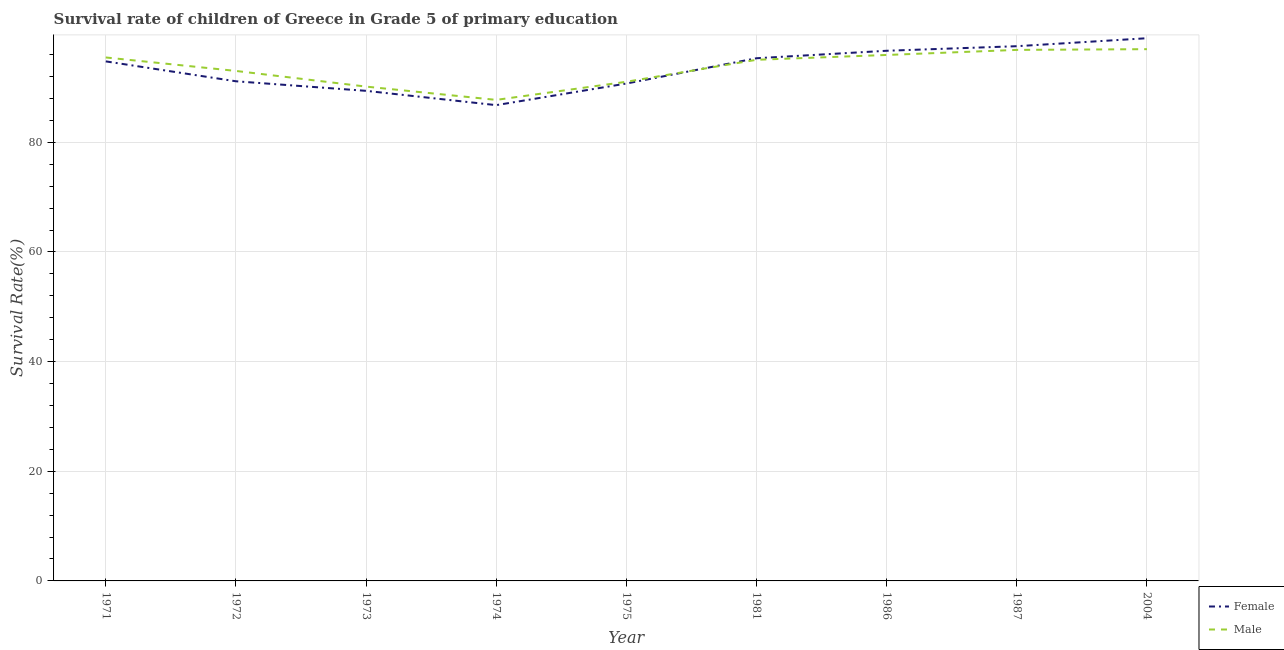How many different coloured lines are there?
Ensure brevity in your answer.  2. Does the line corresponding to survival rate of male students in primary education intersect with the line corresponding to survival rate of female students in primary education?
Your answer should be very brief. Yes. Is the number of lines equal to the number of legend labels?
Offer a very short reply. Yes. What is the survival rate of male students in primary education in 1981?
Ensure brevity in your answer.  95.05. Across all years, what is the maximum survival rate of male students in primary education?
Provide a short and direct response. 96.99. Across all years, what is the minimum survival rate of male students in primary education?
Offer a terse response. 87.74. In which year was the survival rate of female students in primary education maximum?
Your response must be concise. 2004. In which year was the survival rate of male students in primary education minimum?
Your answer should be compact. 1974. What is the total survival rate of female students in primary education in the graph?
Offer a very short reply. 841.33. What is the difference between the survival rate of female students in primary education in 1971 and that in 1975?
Offer a very short reply. 4.04. What is the difference between the survival rate of female students in primary education in 1981 and the survival rate of male students in primary education in 1975?
Offer a very short reply. 4.29. What is the average survival rate of female students in primary education per year?
Your answer should be compact. 93.48. In the year 2004, what is the difference between the survival rate of male students in primary education and survival rate of female students in primary education?
Ensure brevity in your answer.  -2. What is the ratio of the survival rate of female students in primary education in 1971 to that in 2004?
Offer a terse response. 0.96. Is the difference between the survival rate of male students in primary education in 1986 and 2004 greater than the difference between the survival rate of female students in primary education in 1986 and 2004?
Make the answer very short. Yes. What is the difference between the highest and the second highest survival rate of male students in primary education?
Offer a very short reply. 0.13. What is the difference between the highest and the lowest survival rate of female students in primary education?
Provide a succinct answer. 12.21. Is the sum of the survival rate of male students in primary education in 1973 and 1986 greater than the maximum survival rate of female students in primary education across all years?
Offer a terse response. Yes. Is the survival rate of male students in primary education strictly greater than the survival rate of female students in primary education over the years?
Ensure brevity in your answer.  No. Is the survival rate of male students in primary education strictly less than the survival rate of female students in primary education over the years?
Ensure brevity in your answer.  No. How many lines are there?
Keep it short and to the point. 2. How many years are there in the graph?
Your answer should be very brief. 9. What is the difference between two consecutive major ticks on the Y-axis?
Keep it short and to the point. 20. Are the values on the major ticks of Y-axis written in scientific E-notation?
Provide a short and direct response. No. Does the graph contain any zero values?
Offer a terse response. No. Does the graph contain grids?
Your answer should be compact. Yes. Where does the legend appear in the graph?
Offer a very short reply. Bottom right. How many legend labels are there?
Your answer should be very brief. 2. What is the title of the graph?
Your answer should be compact. Survival rate of children of Greece in Grade 5 of primary education. Does "Not attending school" appear as one of the legend labels in the graph?
Offer a terse response. No. What is the label or title of the Y-axis?
Provide a succinct answer. Survival Rate(%). What is the Survival Rate(%) of Female in 1971?
Offer a terse response. 94.76. What is the Survival Rate(%) of Male in 1971?
Keep it short and to the point. 95.48. What is the Survival Rate(%) of Female in 1972?
Ensure brevity in your answer.  91.13. What is the Survival Rate(%) of Male in 1972?
Keep it short and to the point. 93.02. What is the Survival Rate(%) of Female in 1973?
Your answer should be very brief. 89.39. What is the Survival Rate(%) in Male in 1973?
Make the answer very short. 90.16. What is the Survival Rate(%) in Female in 1974?
Offer a very short reply. 86.78. What is the Survival Rate(%) in Male in 1974?
Give a very brief answer. 87.74. What is the Survival Rate(%) of Female in 1975?
Your response must be concise. 90.72. What is the Survival Rate(%) in Male in 1975?
Keep it short and to the point. 91.04. What is the Survival Rate(%) of Female in 1981?
Ensure brevity in your answer.  95.33. What is the Survival Rate(%) in Male in 1981?
Keep it short and to the point. 95.05. What is the Survival Rate(%) in Female in 1986?
Offer a terse response. 96.7. What is the Survival Rate(%) of Male in 1986?
Offer a very short reply. 95.93. What is the Survival Rate(%) in Female in 1987?
Make the answer very short. 97.53. What is the Survival Rate(%) in Male in 1987?
Provide a succinct answer. 96.86. What is the Survival Rate(%) of Female in 2004?
Keep it short and to the point. 98.99. What is the Survival Rate(%) in Male in 2004?
Give a very brief answer. 96.99. Across all years, what is the maximum Survival Rate(%) of Female?
Your response must be concise. 98.99. Across all years, what is the maximum Survival Rate(%) in Male?
Keep it short and to the point. 96.99. Across all years, what is the minimum Survival Rate(%) of Female?
Offer a terse response. 86.78. Across all years, what is the minimum Survival Rate(%) in Male?
Ensure brevity in your answer.  87.74. What is the total Survival Rate(%) in Female in the graph?
Your response must be concise. 841.33. What is the total Survival Rate(%) of Male in the graph?
Provide a short and direct response. 842.27. What is the difference between the Survival Rate(%) of Female in 1971 and that in 1972?
Provide a short and direct response. 3.63. What is the difference between the Survival Rate(%) of Male in 1971 and that in 1972?
Provide a succinct answer. 2.46. What is the difference between the Survival Rate(%) in Female in 1971 and that in 1973?
Keep it short and to the point. 5.37. What is the difference between the Survival Rate(%) in Male in 1971 and that in 1973?
Offer a very short reply. 5.31. What is the difference between the Survival Rate(%) of Female in 1971 and that in 1974?
Make the answer very short. 7.98. What is the difference between the Survival Rate(%) in Male in 1971 and that in 1974?
Your response must be concise. 7.74. What is the difference between the Survival Rate(%) in Female in 1971 and that in 1975?
Provide a short and direct response. 4.04. What is the difference between the Survival Rate(%) of Male in 1971 and that in 1975?
Offer a terse response. 4.43. What is the difference between the Survival Rate(%) of Female in 1971 and that in 1981?
Keep it short and to the point. -0.57. What is the difference between the Survival Rate(%) in Male in 1971 and that in 1981?
Your answer should be very brief. 0.43. What is the difference between the Survival Rate(%) of Female in 1971 and that in 1986?
Give a very brief answer. -1.94. What is the difference between the Survival Rate(%) of Male in 1971 and that in 1986?
Your answer should be compact. -0.45. What is the difference between the Survival Rate(%) of Female in 1971 and that in 1987?
Keep it short and to the point. -2.77. What is the difference between the Survival Rate(%) in Male in 1971 and that in 1987?
Give a very brief answer. -1.38. What is the difference between the Survival Rate(%) in Female in 1971 and that in 2004?
Keep it short and to the point. -4.22. What is the difference between the Survival Rate(%) in Male in 1971 and that in 2004?
Provide a short and direct response. -1.51. What is the difference between the Survival Rate(%) of Female in 1972 and that in 1973?
Your answer should be compact. 1.74. What is the difference between the Survival Rate(%) of Male in 1972 and that in 1973?
Offer a very short reply. 2.86. What is the difference between the Survival Rate(%) of Female in 1972 and that in 1974?
Offer a terse response. 4.35. What is the difference between the Survival Rate(%) in Male in 1972 and that in 1974?
Keep it short and to the point. 5.28. What is the difference between the Survival Rate(%) of Female in 1972 and that in 1975?
Keep it short and to the point. 0.41. What is the difference between the Survival Rate(%) of Male in 1972 and that in 1975?
Offer a very short reply. 1.98. What is the difference between the Survival Rate(%) in Female in 1972 and that in 1981?
Your answer should be compact. -4.2. What is the difference between the Survival Rate(%) of Male in 1972 and that in 1981?
Offer a terse response. -2.03. What is the difference between the Survival Rate(%) of Female in 1972 and that in 1986?
Your answer should be very brief. -5.57. What is the difference between the Survival Rate(%) in Male in 1972 and that in 1986?
Offer a very short reply. -2.91. What is the difference between the Survival Rate(%) in Female in 1972 and that in 1987?
Provide a short and direct response. -6.4. What is the difference between the Survival Rate(%) of Male in 1972 and that in 1987?
Your answer should be compact. -3.84. What is the difference between the Survival Rate(%) of Female in 1972 and that in 2004?
Offer a terse response. -7.85. What is the difference between the Survival Rate(%) of Male in 1972 and that in 2004?
Offer a terse response. -3.97. What is the difference between the Survival Rate(%) in Female in 1973 and that in 1974?
Keep it short and to the point. 2.61. What is the difference between the Survival Rate(%) in Male in 1973 and that in 1974?
Your answer should be compact. 2.43. What is the difference between the Survival Rate(%) in Female in 1973 and that in 1975?
Offer a terse response. -1.33. What is the difference between the Survival Rate(%) in Male in 1973 and that in 1975?
Provide a succinct answer. -0.88. What is the difference between the Survival Rate(%) of Female in 1973 and that in 1981?
Your answer should be compact. -5.95. What is the difference between the Survival Rate(%) in Male in 1973 and that in 1981?
Your answer should be compact. -4.89. What is the difference between the Survival Rate(%) in Female in 1973 and that in 1986?
Offer a very short reply. -7.31. What is the difference between the Survival Rate(%) of Male in 1973 and that in 1986?
Your response must be concise. -5.77. What is the difference between the Survival Rate(%) of Female in 1973 and that in 1987?
Keep it short and to the point. -8.14. What is the difference between the Survival Rate(%) of Male in 1973 and that in 1987?
Your answer should be very brief. -6.69. What is the difference between the Survival Rate(%) of Female in 1973 and that in 2004?
Give a very brief answer. -9.6. What is the difference between the Survival Rate(%) of Male in 1973 and that in 2004?
Your answer should be compact. -6.83. What is the difference between the Survival Rate(%) in Female in 1974 and that in 1975?
Provide a succinct answer. -3.94. What is the difference between the Survival Rate(%) of Male in 1974 and that in 1975?
Keep it short and to the point. -3.31. What is the difference between the Survival Rate(%) of Female in 1974 and that in 1981?
Give a very brief answer. -8.55. What is the difference between the Survival Rate(%) in Male in 1974 and that in 1981?
Your response must be concise. -7.31. What is the difference between the Survival Rate(%) of Female in 1974 and that in 1986?
Offer a very short reply. -9.92. What is the difference between the Survival Rate(%) of Male in 1974 and that in 1986?
Your response must be concise. -8.19. What is the difference between the Survival Rate(%) of Female in 1974 and that in 1987?
Your answer should be compact. -10.75. What is the difference between the Survival Rate(%) of Male in 1974 and that in 1987?
Offer a terse response. -9.12. What is the difference between the Survival Rate(%) in Female in 1974 and that in 2004?
Provide a short and direct response. -12.21. What is the difference between the Survival Rate(%) in Male in 1974 and that in 2004?
Your response must be concise. -9.25. What is the difference between the Survival Rate(%) in Female in 1975 and that in 1981?
Provide a short and direct response. -4.61. What is the difference between the Survival Rate(%) of Male in 1975 and that in 1981?
Your answer should be very brief. -4.01. What is the difference between the Survival Rate(%) of Female in 1975 and that in 1986?
Make the answer very short. -5.98. What is the difference between the Survival Rate(%) in Male in 1975 and that in 1986?
Provide a succinct answer. -4.89. What is the difference between the Survival Rate(%) of Female in 1975 and that in 1987?
Your response must be concise. -6.81. What is the difference between the Survival Rate(%) in Male in 1975 and that in 1987?
Provide a short and direct response. -5.81. What is the difference between the Survival Rate(%) of Female in 1975 and that in 2004?
Your answer should be very brief. -8.27. What is the difference between the Survival Rate(%) of Male in 1975 and that in 2004?
Offer a very short reply. -5.95. What is the difference between the Survival Rate(%) of Female in 1981 and that in 1986?
Give a very brief answer. -1.36. What is the difference between the Survival Rate(%) of Male in 1981 and that in 1986?
Your answer should be very brief. -0.88. What is the difference between the Survival Rate(%) of Female in 1981 and that in 1987?
Ensure brevity in your answer.  -2.2. What is the difference between the Survival Rate(%) of Male in 1981 and that in 1987?
Your answer should be compact. -1.8. What is the difference between the Survival Rate(%) in Female in 1981 and that in 2004?
Make the answer very short. -3.65. What is the difference between the Survival Rate(%) in Male in 1981 and that in 2004?
Your answer should be compact. -1.94. What is the difference between the Survival Rate(%) in Female in 1986 and that in 1987?
Offer a very short reply. -0.83. What is the difference between the Survival Rate(%) of Male in 1986 and that in 1987?
Give a very brief answer. -0.92. What is the difference between the Survival Rate(%) of Female in 1986 and that in 2004?
Offer a very short reply. -2.29. What is the difference between the Survival Rate(%) of Male in 1986 and that in 2004?
Give a very brief answer. -1.06. What is the difference between the Survival Rate(%) of Female in 1987 and that in 2004?
Keep it short and to the point. -1.46. What is the difference between the Survival Rate(%) in Male in 1987 and that in 2004?
Keep it short and to the point. -0.13. What is the difference between the Survival Rate(%) of Female in 1971 and the Survival Rate(%) of Male in 1972?
Make the answer very short. 1.74. What is the difference between the Survival Rate(%) of Female in 1971 and the Survival Rate(%) of Male in 1973?
Make the answer very short. 4.6. What is the difference between the Survival Rate(%) of Female in 1971 and the Survival Rate(%) of Male in 1974?
Give a very brief answer. 7.02. What is the difference between the Survival Rate(%) of Female in 1971 and the Survival Rate(%) of Male in 1975?
Make the answer very short. 3.72. What is the difference between the Survival Rate(%) of Female in 1971 and the Survival Rate(%) of Male in 1981?
Your answer should be compact. -0.29. What is the difference between the Survival Rate(%) in Female in 1971 and the Survival Rate(%) in Male in 1986?
Your response must be concise. -1.17. What is the difference between the Survival Rate(%) in Female in 1971 and the Survival Rate(%) in Male in 1987?
Give a very brief answer. -2.09. What is the difference between the Survival Rate(%) in Female in 1971 and the Survival Rate(%) in Male in 2004?
Your response must be concise. -2.23. What is the difference between the Survival Rate(%) in Female in 1972 and the Survival Rate(%) in Male in 1973?
Ensure brevity in your answer.  0.97. What is the difference between the Survival Rate(%) of Female in 1972 and the Survival Rate(%) of Male in 1974?
Ensure brevity in your answer.  3.39. What is the difference between the Survival Rate(%) of Female in 1972 and the Survival Rate(%) of Male in 1975?
Offer a terse response. 0.09. What is the difference between the Survival Rate(%) in Female in 1972 and the Survival Rate(%) in Male in 1981?
Make the answer very short. -3.92. What is the difference between the Survival Rate(%) of Female in 1972 and the Survival Rate(%) of Male in 1986?
Offer a very short reply. -4.8. What is the difference between the Survival Rate(%) of Female in 1972 and the Survival Rate(%) of Male in 1987?
Your response must be concise. -5.72. What is the difference between the Survival Rate(%) of Female in 1972 and the Survival Rate(%) of Male in 2004?
Make the answer very short. -5.86. What is the difference between the Survival Rate(%) of Female in 1973 and the Survival Rate(%) of Male in 1974?
Your answer should be very brief. 1.65. What is the difference between the Survival Rate(%) of Female in 1973 and the Survival Rate(%) of Male in 1975?
Offer a very short reply. -1.65. What is the difference between the Survival Rate(%) of Female in 1973 and the Survival Rate(%) of Male in 1981?
Make the answer very short. -5.66. What is the difference between the Survival Rate(%) in Female in 1973 and the Survival Rate(%) in Male in 1986?
Give a very brief answer. -6.54. What is the difference between the Survival Rate(%) of Female in 1973 and the Survival Rate(%) of Male in 1987?
Your response must be concise. -7.47. What is the difference between the Survival Rate(%) of Female in 1973 and the Survival Rate(%) of Male in 2004?
Your answer should be very brief. -7.6. What is the difference between the Survival Rate(%) of Female in 1974 and the Survival Rate(%) of Male in 1975?
Your answer should be compact. -4.26. What is the difference between the Survival Rate(%) in Female in 1974 and the Survival Rate(%) in Male in 1981?
Make the answer very short. -8.27. What is the difference between the Survival Rate(%) in Female in 1974 and the Survival Rate(%) in Male in 1986?
Your answer should be compact. -9.15. What is the difference between the Survival Rate(%) of Female in 1974 and the Survival Rate(%) of Male in 1987?
Provide a succinct answer. -10.08. What is the difference between the Survival Rate(%) in Female in 1974 and the Survival Rate(%) in Male in 2004?
Offer a very short reply. -10.21. What is the difference between the Survival Rate(%) of Female in 1975 and the Survival Rate(%) of Male in 1981?
Keep it short and to the point. -4.33. What is the difference between the Survival Rate(%) of Female in 1975 and the Survival Rate(%) of Male in 1986?
Keep it short and to the point. -5.21. What is the difference between the Survival Rate(%) of Female in 1975 and the Survival Rate(%) of Male in 1987?
Offer a very short reply. -6.14. What is the difference between the Survival Rate(%) of Female in 1975 and the Survival Rate(%) of Male in 2004?
Provide a short and direct response. -6.27. What is the difference between the Survival Rate(%) in Female in 1981 and the Survival Rate(%) in Male in 1986?
Your response must be concise. -0.6. What is the difference between the Survival Rate(%) of Female in 1981 and the Survival Rate(%) of Male in 1987?
Offer a very short reply. -1.52. What is the difference between the Survival Rate(%) of Female in 1981 and the Survival Rate(%) of Male in 2004?
Your response must be concise. -1.66. What is the difference between the Survival Rate(%) in Female in 1986 and the Survival Rate(%) in Male in 1987?
Provide a short and direct response. -0.16. What is the difference between the Survival Rate(%) of Female in 1986 and the Survival Rate(%) of Male in 2004?
Give a very brief answer. -0.29. What is the difference between the Survival Rate(%) of Female in 1987 and the Survival Rate(%) of Male in 2004?
Offer a terse response. 0.54. What is the average Survival Rate(%) in Female per year?
Your answer should be compact. 93.48. What is the average Survival Rate(%) of Male per year?
Your answer should be compact. 93.59. In the year 1971, what is the difference between the Survival Rate(%) of Female and Survival Rate(%) of Male?
Provide a succinct answer. -0.72. In the year 1972, what is the difference between the Survival Rate(%) of Female and Survival Rate(%) of Male?
Your response must be concise. -1.89. In the year 1973, what is the difference between the Survival Rate(%) in Female and Survival Rate(%) in Male?
Give a very brief answer. -0.77. In the year 1974, what is the difference between the Survival Rate(%) of Female and Survival Rate(%) of Male?
Provide a short and direct response. -0.96. In the year 1975, what is the difference between the Survival Rate(%) in Female and Survival Rate(%) in Male?
Your answer should be compact. -0.32. In the year 1981, what is the difference between the Survival Rate(%) in Female and Survival Rate(%) in Male?
Keep it short and to the point. 0.28. In the year 1986, what is the difference between the Survival Rate(%) in Female and Survival Rate(%) in Male?
Ensure brevity in your answer.  0.77. In the year 1987, what is the difference between the Survival Rate(%) of Female and Survival Rate(%) of Male?
Offer a terse response. 0.67. In the year 2004, what is the difference between the Survival Rate(%) in Female and Survival Rate(%) in Male?
Keep it short and to the point. 2. What is the ratio of the Survival Rate(%) of Female in 1971 to that in 1972?
Your response must be concise. 1.04. What is the ratio of the Survival Rate(%) of Male in 1971 to that in 1972?
Offer a very short reply. 1.03. What is the ratio of the Survival Rate(%) of Female in 1971 to that in 1973?
Provide a succinct answer. 1.06. What is the ratio of the Survival Rate(%) of Male in 1971 to that in 1973?
Your answer should be compact. 1.06. What is the ratio of the Survival Rate(%) in Female in 1971 to that in 1974?
Your answer should be very brief. 1.09. What is the ratio of the Survival Rate(%) of Male in 1971 to that in 1974?
Provide a short and direct response. 1.09. What is the ratio of the Survival Rate(%) in Female in 1971 to that in 1975?
Offer a very short reply. 1.04. What is the ratio of the Survival Rate(%) of Male in 1971 to that in 1975?
Keep it short and to the point. 1.05. What is the ratio of the Survival Rate(%) in Female in 1971 to that in 1986?
Offer a terse response. 0.98. What is the ratio of the Survival Rate(%) of Female in 1971 to that in 1987?
Provide a short and direct response. 0.97. What is the ratio of the Survival Rate(%) of Male in 1971 to that in 1987?
Give a very brief answer. 0.99. What is the ratio of the Survival Rate(%) in Female in 1971 to that in 2004?
Offer a terse response. 0.96. What is the ratio of the Survival Rate(%) in Male in 1971 to that in 2004?
Your response must be concise. 0.98. What is the ratio of the Survival Rate(%) in Female in 1972 to that in 1973?
Provide a succinct answer. 1.02. What is the ratio of the Survival Rate(%) of Male in 1972 to that in 1973?
Ensure brevity in your answer.  1.03. What is the ratio of the Survival Rate(%) in Female in 1972 to that in 1974?
Give a very brief answer. 1.05. What is the ratio of the Survival Rate(%) of Male in 1972 to that in 1974?
Your answer should be compact. 1.06. What is the ratio of the Survival Rate(%) of Male in 1972 to that in 1975?
Ensure brevity in your answer.  1.02. What is the ratio of the Survival Rate(%) of Female in 1972 to that in 1981?
Provide a succinct answer. 0.96. What is the ratio of the Survival Rate(%) in Male in 1972 to that in 1981?
Provide a succinct answer. 0.98. What is the ratio of the Survival Rate(%) in Female in 1972 to that in 1986?
Ensure brevity in your answer.  0.94. What is the ratio of the Survival Rate(%) in Male in 1972 to that in 1986?
Keep it short and to the point. 0.97. What is the ratio of the Survival Rate(%) of Female in 1972 to that in 1987?
Offer a very short reply. 0.93. What is the ratio of the Survival Rate(%) in Male in 1972 to that in 1987?
Offer a terse response. 0.96. What is the ratio of the Survival Rate(%) of Female in 1972 to that in 2004?
Make the answer very short. 0.92. What is the ratio of the Survival Rate(%) of Male in 1972 to that in 2004?
Your answer should be compact. 0.96. What is the ratio of the Survival Rate(%) in Female in 1973 to that in 1974?
Make the answer very short. 1.03. What is the ratio of the Survival Rate(%) of Male in 1973 to that in 1974?
Keep it short and to the point. 1.03. What is the ratio of the Survival Rate(%) of Female in 1973 to that in 1975?
Your answer should be compact. 0.99. What is the ratio of the Survival Rate(%) of Male in 1973 to that in 1975?
Keep it short and to the point. 0.99. What is the ratio of the Survival Rate(%) in Female in 1973 to that in 1981?
Provide a succinct answer. 0.94. What is the ratio of the Survival Rate(%) in Male in 1973 to that in 1981?
Make the answer very short. 0.95. What is the ratio of the Survival Rate(%) of Female in 1973 to that in 1986?
Offer a very short reply. 0.92. What is the ratio of the Survival Rate(%) in Male in 1973 to that in 1986?
Your answer should be very brief. 0.94. What is the ratio of the Survival Rate(%) of Female in 1973 to that in 1987?
Your answer should be very brief. 0.92. What is the ratio of the Survival Rate(%) in Male in 1973 to that in 1987?
Your response must be concise. 0.93. What is the ratio of the Survival Rate(%) in Female in 1973 to that in 2004?
Offer a terse response. 0.9. What is the ratio of the Survival Rate(%) in Male in 1973 to that in 2004?
Keep it short and to the point. 0.93. What is the ratio of the Survival Rate(%) of Female in 1974 to that in 1975?
Give a very brief answer. 0.96. What is the ratio of the Survival Rate(%) of Male in 1974 to that in 1975?
Keep it short and to the point. 0.96. What is the ratio of the Survival Rate(%) of Female in 1974 to that in 1981?
Offer a very short reply. 0.91. What is the ratio of the Survival Rate(%) of Male in 1974 to that in 1981?
Offer a terse response. 0.92. What is the ratio of the Survival Rate(%) of Female in 1974 to that in 1986?
Ensure brevity in your answer.  0.9. What is the ratio of the Survival Rate(%) of Male in 1974 to that in 1986?
Provide a short and direct response. 0.91. What is the ratio of the Survival Rate(%) of Female in 1974 to that in 1987?
Provide a succinct answer. 0.89. What is the ratio of the Survival Rate(%) in Male in 1974 to that in 1987?
Your answer should be very brief. 0.91. What is the ratio of the Survival Rate(%) of Female in 1974 to that in 2004?
Keep it short and to the point. 0.88. What is the ratio of the Survival Rate(%) in Male in 1974 to that in 2004?
Provide a short and direct response. 0.9. What is the ratio of the Survival Rate(%) of Female in 1975 to that in 1981?
Your answer should be compact. 0.95. What is the ratio of the Survival Rate(%) of Male in 1975 to that in 1981?
Offer a very short reply. 0.96. What is the ratio of the Survival Rate(%) in Female in 1975 to that in 1986?
Offer a terse response. 0.94. What is the ratio of the Survival Rate(%) of Male in 1975 to that in 1986?
Ensure brevity in your answer.  0.95. What is the ratio of the Survival Rate(%) of Female in 1975 to that in 1987?
Give a very brief answer. 0.93. What is the ratio of the Survival Rate(%) in Male in 1975 to that in 1987?
Provide a succinct answer. 0.94. What is the ratio of the Survival Rate(%) of Female in 1975 to that in 2004?
Provide a succinct answer. 0.92. What is the ratio of the Survival Rate(%) in Male in 1975 to that in 2004?
Provide a short and direct response. 0.94. What is the ratio of the Survival Rate(%) in Female in 1981 to that in 1986?
Keep it short and to the point. 0.99. What is the ratio of the Survival Rate(%) in Male in 1981 to that in 1986?
Give a very brief answer. 0.99. What is the ratio of the Survival Rate(%) in Female in 1981 to that in 1987?
Offer a terse response. 0.98. What is the ratio of the Survival Rate(%) of Male in 1981 to that in 1987?
Your answer should be very brief. 0.98. What is the ratio of the Survival Rate(%) in Female in 1981 to that in 2004?
Give a very brief answer. 0.96. What is the ratio of the Survival Rate(%) of Male in 1981 to that in 2004?
Provide a succinct answer. 0.98. What is the ratio of the Survival Rate(%) in Female in 1986 to that in 1987?
Your response must be concise. 0.99. What is the ratio of the Survival Rate(%) in Male in 1986 to that in 1987?
Provide a succinct answer. 0.99. What is the ratio of the Survival Rate(%) in Female in 1986 to that in 2004?
Provide a succinct answer. 0.98. What is the ratio of the Survival Rate(%) of Male in 1986 to that in 2004?
Give a very brief answer. 0.99. What is the difference between the highest and the second highest Survival Rate(%) of Female?
Provide a short and direct response. 1.46. What is the difference between the highest and the second highest Survival Rate(%) in Male?
Keep it short and to the point. 0.13. What is the difference between the highest and the lowest Survival Rate(%) in Female?
Your response must be concise. 12.21. What is the difference between the highest and the lowest Survival Rate(%) of Male?
Provide a short and direct response. 9.25. 